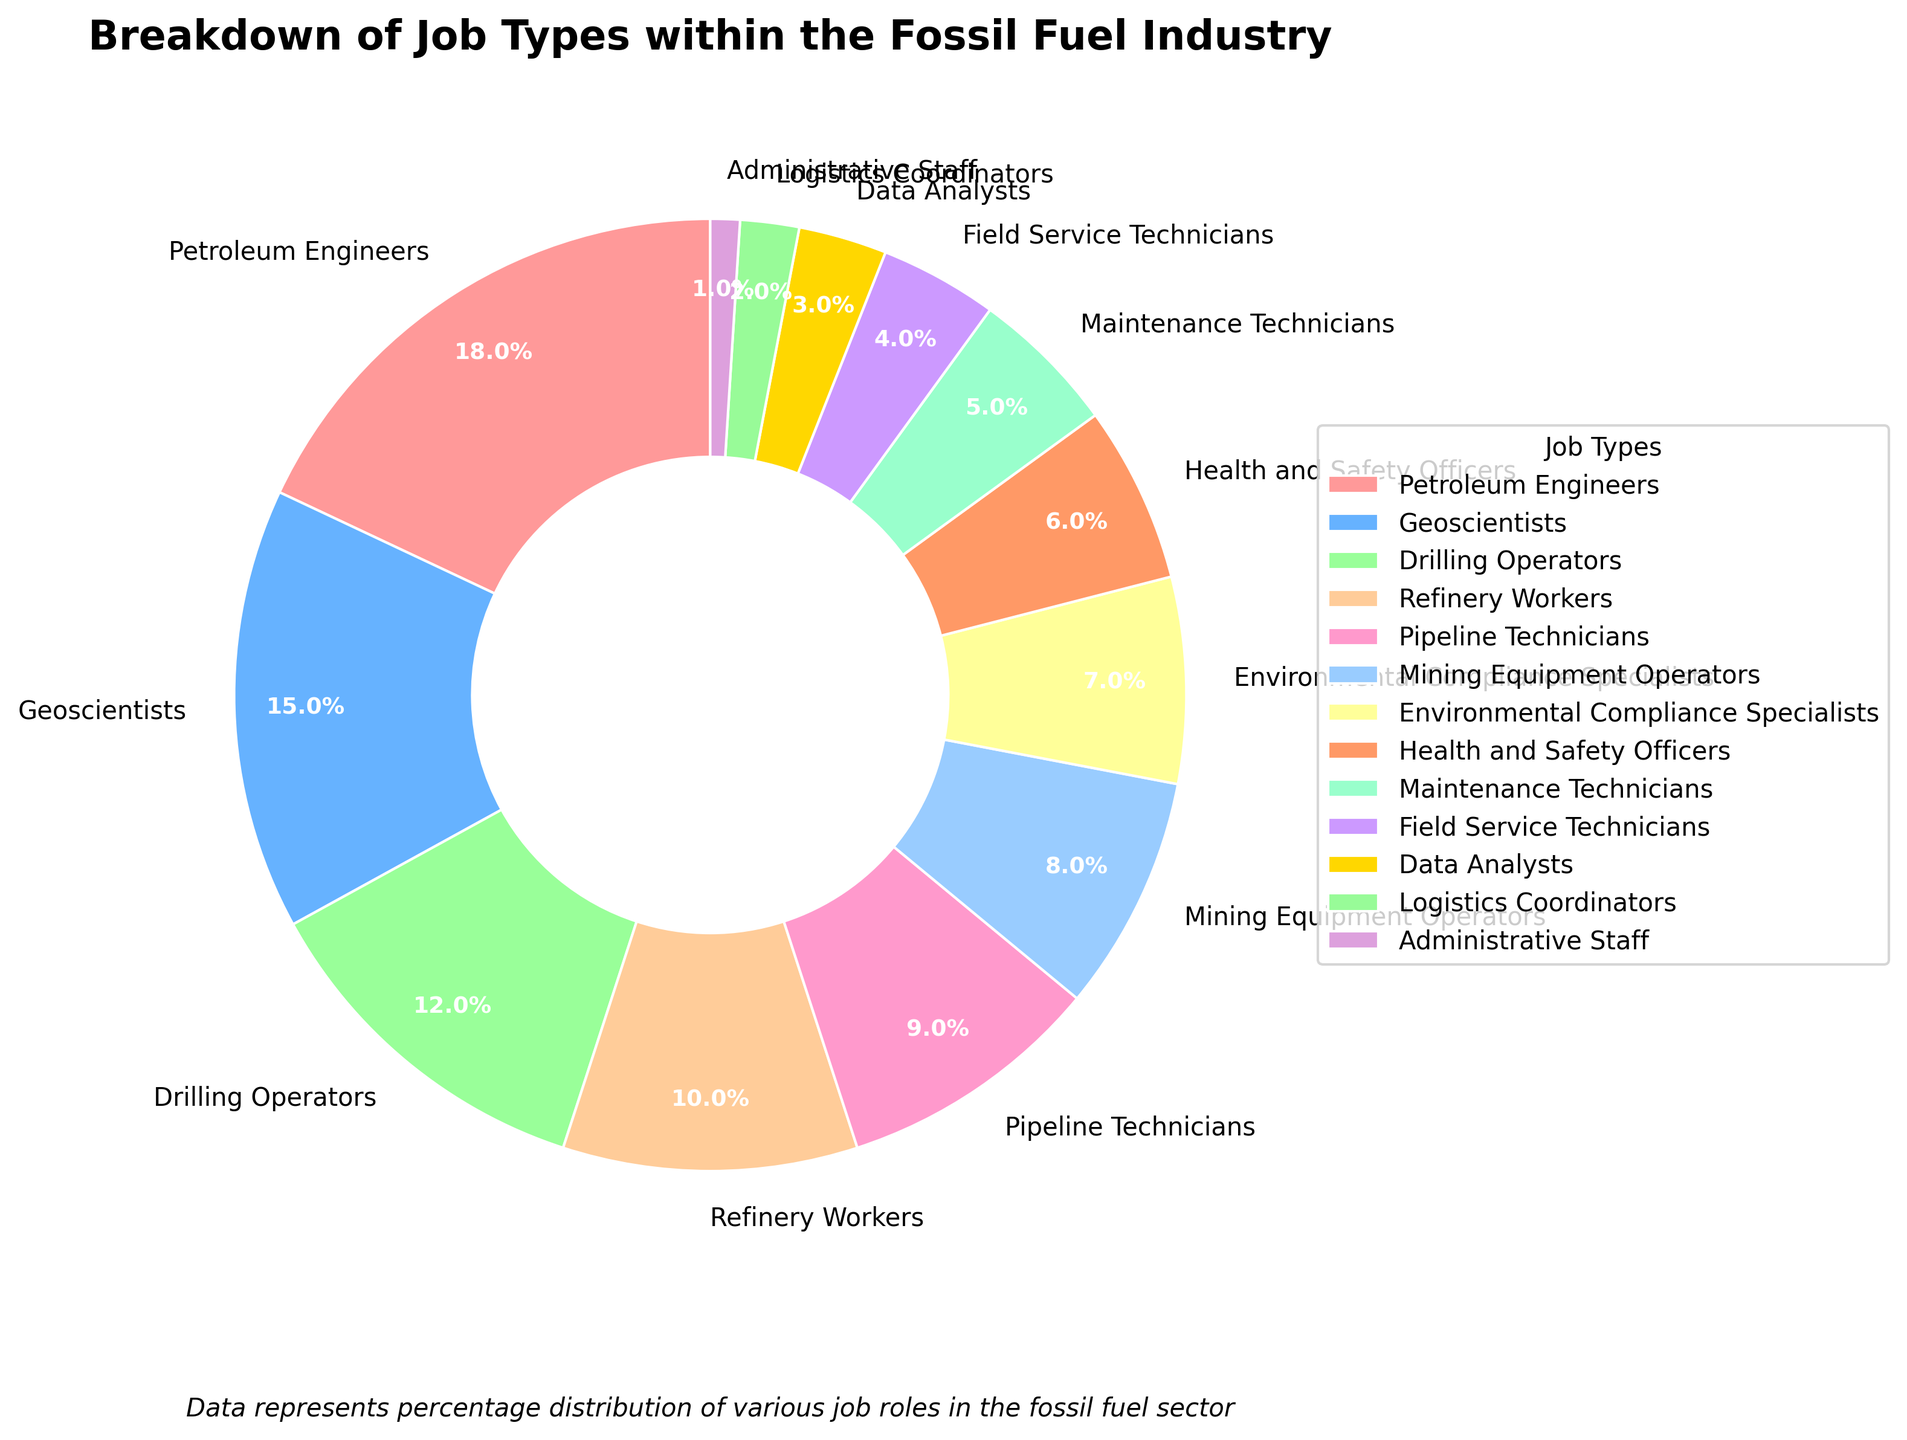What is the total percentage of jobs accounted for by Petroleum Engineers, Geoscientists, and Drilling Operators together? To find the total percentage of these three job types, you sum their individual percentages: Petroleum Engineers (18%), Geoscientists (15%), and Drilling Operators (12%). So, 18 + 15 + 12 = 45.
Answer: 45 Which job type has the lowest percentage in the fossil fuel industry? By examining the pie chart, we can identify the segment with the smallest slice, which corresponds to Administrative Staff at 1%.
Answer: Administrative Staff How much more percentage do Petroleum Engineers contribute compared to Environmental Compliance Specialists? First, note the percentages: Petroleum Engineers (18%) and Environmental Compliance Specialists (7%). Subtract the smaller percentage from the larger one: 18 - 7 = 11.
Answer: 11 Are there more Geoscientists or Maintenance Technicians, and by what percentage? Geoscientists make up 15% while Maintenance Technicians make up 5%. The difference between them is 15 - 5 = 10. Geoscientists have a higher percentage.
Answer: Geoscientists, 10 What is the combined percentage of Field Service Technicians and Logistics Coordinators? Add the percentages for Field Service Technicians (4%) and Logistics Coordinators (2%). 4 + 2 = 6.
Answer: 6 Does the sum of the percentages of jobs related to compliance and safety (Environmental Compliance Specialists and Health and Safety Officers) exceed that of Petroleum Engineers? Environmental Compliance Specialists are 7% and Health and Safety Officers are 6%. Their combined percentage is 7 + 6 = 13%. Petroleum Engineers are 18%. Thus, 13% does not exceed 18%.
Answer: No Which job contributes more to the total, Drilling Operators or Pipeline Technicians, and by how much? Drilling Operators account for 12%, while Pipeline Technicians account for 9%. Subtract the smaller percentage from the larger: 12 - 9 = 3.
Answer: Drilling Operators, 3 What is the difference in percentage between Mining Equipment Operators and Data Analysts? Mining Equipment Operators represent 8% while Data Analysts represent 3%. The difference between these two percentages is 8 - 3 = 5.
Answer: 5 How many job types have a percentage of 10% or more? Petroleum Engineers (18%), Geoscientists (15%), Drilling Operators (12%), and Refinery Workers (10%) each have a percentage of 10% or more. Counting these, we get a total of 4 job types.
Answer: 4 Is the percentage of jobs attributed to Health and Safety Officers greater than the combined percentage of Administrative Staff and Logistics Coordinators? Health and Safety Officers contribute 6%. The combined percentage for Administrative Staff (1%) and Logistics Coordinators (2%) is 1 + 2 = 3%. Since 6% is greater than 3%, the statement is true.
Answer: Yes 